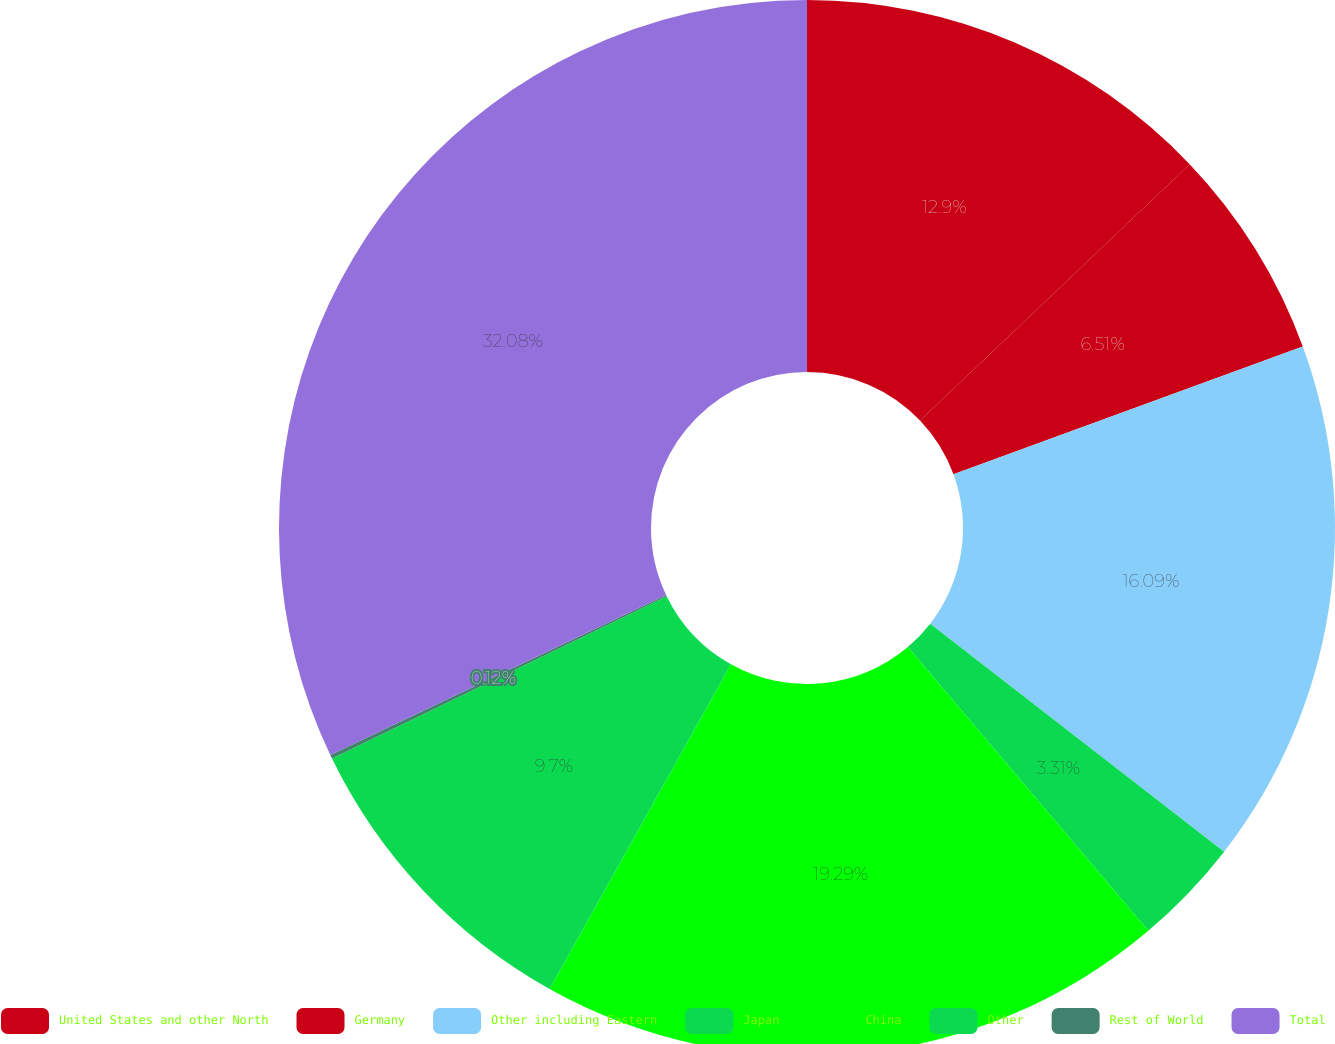Convert chart to OTSL. <chart><loc_0><loc_0><loc_500><loc_500><pie_chart><fcel>United States and other North<fcel>Germany<fcel>Other including Eastern<fcel>Japan<fcel>China<fcel>Other<fcel>Rest of World<fcel>Total<nl><fcel>12.9%<fcel>6.51%<fcel>16.09%<fcel>3.31%<fcel>19.29%<fcel>9.7%<fcel>0.12%<fcel>32.07%<nl></chart> 